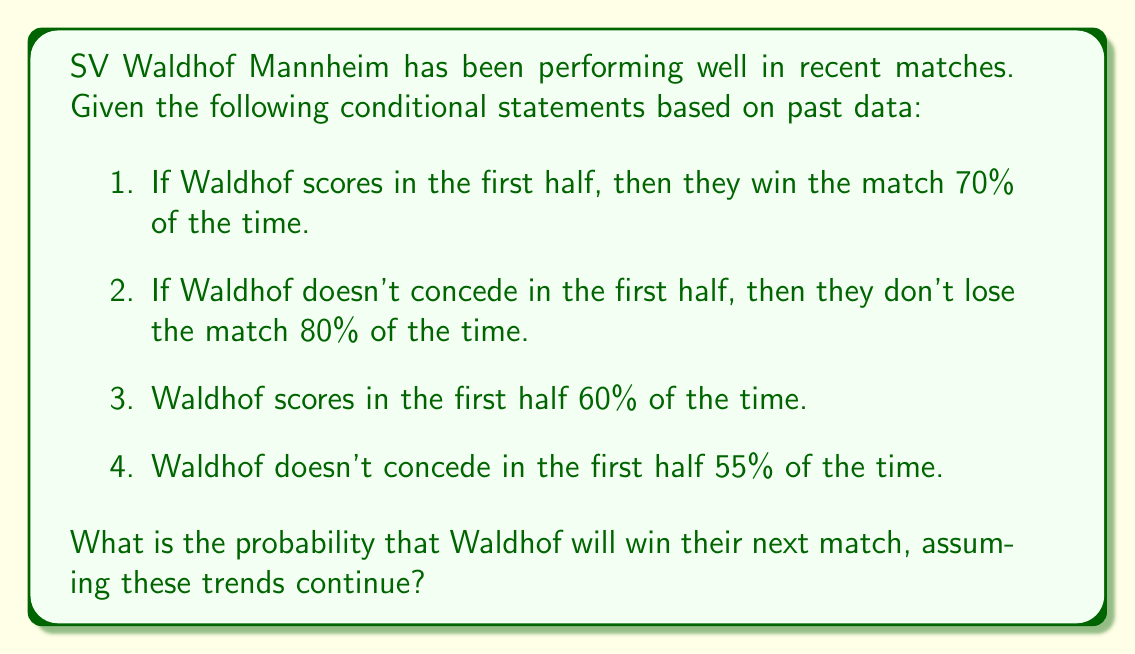Teach me how to tackle this problem. Let's approach this step-by-step using the given conditional statements and probability theory:

1. Let's define our events:
   $W$: Waldhof wins the match
   $S$: Waldhof scores in the first half
   $N$: Waldhof doesn't concede in the first half

2. From the given information:
   $P(W|S) = 0.7$ (probability of winning given they score in the first half)
   $P(S) = 0.6$ (probability of scoring in the first half)
   $P(N) = 0.55$ (probability of not conceding in the first half)

3. We can use the law of total probability to calculate the probability of winning:

   $P(W) = P(W|S) \cdot P(S) + P(W|\neg S) \cdot P(\neg S)$

4. We know $P(W|S)$, $P(S)$, and $P(\neg S) = 1 - P(S) = 0.4$, but we don't know $P(W|\neg S)$. However, we can estimate it using the other information:

   If they don't concede in the first half, they don't lose 80% of the time. This means they either win or draw. Let's assume these outcomes are equally likely when they don't concede. So:

   $P(W|N) \approx 0.4$ (half of the 80% probability of not losing)

5. We can use this as an approximation for $P(W|\neg S)$, although it's not exactly the same thing. It's the best estimate we can make with the given information.

6. Now we can calculate:

   $P(W) \approx 0.7 \cdot 0.6 + 0.4 \cdot 0.4 = 0.42 + 0.16 = 0.58$

Therefore, based on these conditional statements and assumptions, the probability that Waldhof will win their next match is approximately 0.58 or 58%.
Answer: Approximately 0.58 or 58% 